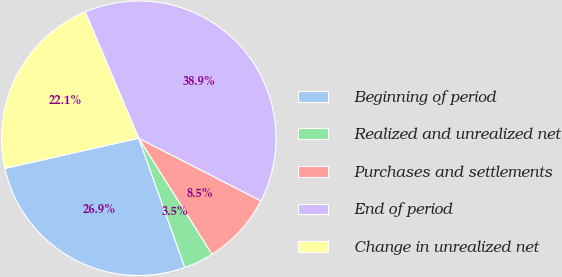<chart> <loc_0><loc_0><loc_500><loc_500><pie_chart><fcel>Beginning of period<fcel>Realized and unrealized net<fcel>Purchases and settlements<fcel>End of period<fcel>Change in unrealized net<nl><fcel>26.92%<fcel>3.52%<fcel>8.49%<fcel>38.92%<fcel>22.15%<nl></chart> 